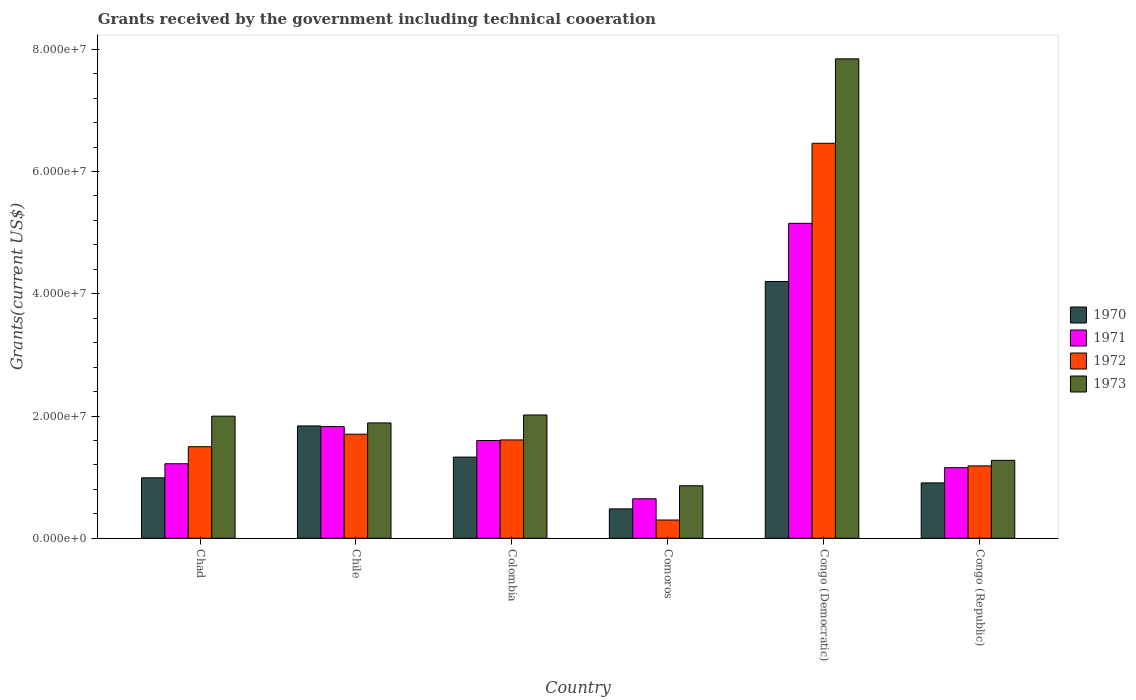How many different coloured bars are there?
Ensure brevity in your answer.  4. Are the number of bars per tick equal to the number of legend labels?
Give a very brief answer. Yes. Are the number of bars on each tick of the X-axis equal?
Your answer should be very brief. Yes. What is the label of the 6th group of bars from the left?
Your answer should be very brief. Congo (Republic). What is the total grants received by the government in 1972 in Comoros?
Make the answer very short. 2.99e+06. Across all countries, what is the maximum total grants received by the government in 1972?
Your answer should be very brief. 6.46e+07. Across all countries, what is the minimum total grants received by the government in 1972?
Offer a very short reply. 2.99e+06. In which country was the total grants received by the government in 1972 maximum?
Your answer should be very brief. Congo (Democratic). In which country was the total grants received by the government in 1972 minimum?
Your answer should be compact. Comoros. What is the total total grants received by the government in 1972 in the graph?
Offer a very short reply. 1.28e+08. What is the difference between the total grants received by the government in 1972 in Chad and that in Chile?
Offer a terse response. -2.05e+06. What is the difference between the total grants received by the government in 1972 in Comoros and the total grants received by the government in 1970 in Chad?
Your response must be concise. -6.90e+06. What is the average total grants received by the government in 1972 per country?
Ensure brevity in your answer.  2.13e+07. What is the difference between the total grants received by the government of/in 1971 and total grants received by the government of/in 1970 in Comoros?
Keep it short and to the point. 1.65e+06. In how many countries, is the total grants received by the government in 1970 greater than 40000000 US$?
Your answer should be very brief. 1. What is the ratio of the total grants received by the government in 1973 in Chad to that in Congo (Democratic)?
Keep it short and to the point. 0.25. Is the total grants received by the government in 1972 in Colombia less than that in Congo (Democratic)?
Your answer should be very brief. Yes. Is the difference between the total grants received by the government in 1971 in Chad and Comoros greater than the difference between the total grants received by the government in 1970 in Chad and Comoros?
Make the answer very short. Yes. What is the difference between the highest and the second highest total grants received by the government in 1970?
Your response must be concise. 2.87e+07. What is the difference between the highest and the lowest total grants received by the government in 1970?
Offer a terse response. 3.72e+07. Is the sum of the total grants received by the government in 1973 in Chad and Congo (Republic) greater than the maximum total grants received by the government in 1971 across all countries?
Ensure brevity in your answer.  No. Is it the case that in every country, the sum of the total grants received by the government in 1971 and total grants received by the government in 1970 is greater than the sum of total grants received by the government in 1973 and total grants received by the government in 1972?
Offer a terse response. No. What does the 3rd bar from the right in Chad represents?
Keep it short and to the point. 1971. How many bars are there?
Give a very brief answer. 24. Are all the bars in the graph horizontal?
Offer a terse response. No. What is the difference between two consecutive major ticks on the Y-axis?
Keep it short and to the point. 2.00e+07. Are the values on the major ticks of Y-axis written in scientific E-notation?
Offer a very short reply. Yes. Does the graph contain any zero values?
Your answer should be very brief. No. How many legend labels are there?
Provide a succinct answer. 4. What is the title of the graph?
Ensure brevity in your answer.  Grants received by the government including technical cooeration. Does "2002" appear as one of the legend labels in the graph?
Ensure brevity in your answer.  No. What is the label or title of the Y-axis?
Offer a very short reply. Grants(current US$). What is the Grants(current US$) in 1970 in Chad?
Offer a terse response. 9.89e+06. What is the Grants(current US$) in 1971 in Chad?
Your response must be concise. 1.22e+07. What is the Grants(current US$) in 1972 in Chad?
Ensure brevity in your answer.  1.50e+07. What is the Grants(current US$) in 1973 in Chad?
Provide a short and direct response. 2.00e+07. What is the Grants(current US$) in 1970 in Chile?
Keep it short and to the point. 1.84e+07. What is the Grants(current US$) in 1971 in Chile?
Offer a very short reply. 1.83e+07. What is the Grants(current US$) of 1972 in Chile?
Your answer should be very brief. 1.70e+07. What is the Grants(current US$) of 1973 in Chile?
Offer a terse response. 1.89e+07. What is the Grants(current US$) of 1970 in Colombia?
Make the answer very short. 1.33e+07. What is the Grants(current US$) of 1971 in Colombia?
Offer a very short reply. 1.60e+07. What is the Grants(current US$) in 1972 in Colombia?
Offer a terse response. 1.61e+07. What is the Grants(current US$) of 1973 in Colombia?
Give a very brief answer. 2.02e+07. What is the Grants(current US$) in 1970 in Comoros?
Provide a short and direct response. 4.81e+06. What is the Grants(current US$) in 1971 in Comoros?
Your response must be concise. 6.46e+06. What is the Grants(current US$) in 1972 in Comoros?
Provide a succinct answer. 2.99e+06. What is the Grants(current US$) in 1973 in Comoros?
Ensure brevity in your answer.  8.59e+06. What is the Grants(current US$) of 1970 in Congo (Democratic)?
Provide a succinct answer. 4.20e+07. What is the Grants(current US$) of 1971 in Congo (Democratic)?
Ensure brevity in your answer.  5.15e+07. What is the Grants(current US$) in 1972 in Congo (Democratic)?
Provide a succinct answer. 6.46e+07. What is the Grants(current US$) in 1973 in Congo (Democratic)?
Give a very brief answer. 7.84e+07. What is the Grants(current US$) of 1970 in Congo (Republic)?
Your answer should be compact. 9.06e+06. What is the Grants(current US$) in 1971 in Congo (Republic)?
Keep it short and to the point. 1.16e+07. What is the Grants(current US$) in 1972 in Congo (Republic)?
Your answer should be compact. 1.18e+07. What is the Grants(current US$) in 1973 in Congo (Republic)?
Keep it short and to the point. 1.28e+07. Across all countries, what is the maximum Grants(current US$) in 1970?
Offer a terse response. 4.20e+07. Across all countries, what is the maximum Grants(current US$) in 1971?
Provide a succinct answer. 5.15e+07. Across all countries, what is the maximum Grants(current US$) in 1972?
Offer a terse response. 6.46e+07. Across all countries, what is the maximum Grants(current US$) in 1973?
Your response must be concise. 7.84e+07. Across all countries, what is the minimum Grants(current US$) in 1970?
Offer a terse response. 4.81e+06. Across all countries, what is the minimum Grants(current US$) in 1971?
Provide a succinct answer. 6.46e+06. Across all countries, what is the minimum Grants(current US$) in 1972?
Your response must be concise. 2.99e+06. Across all countries, what is the minimum Grants(current US$) in 1973?
Your answer should be very brief. 8.59e+06. What is the total Grants(current US$) in 1970 in the graph?
Offer a terse response. 9.74e+07. What is the total Grants(current US$) in 1971 in the graph?
Give a very brief answer. 1.16e+08. What is the total Grants(current US$) in 1972 in the graph?
Your answer should be very brief. 1.28e+08. What is the total Grants(current US$) in 1973 in the graph?
Your response must be concise. 1.59e+08. What is the difference between the Grants(current US$) in 1970 in Chad and that in Chile?
Your response must be concise. -8.49e+06. What is the difference between the Grants(current US$) of 1971 in Chad and that in Chile?
Keep it short and to the point. -6.08e+06. What is the difference between the Grants(current US$) of 1972 in Chad and that in Chile?
Offer a terse response. -2.05e+06. What is the difference between the Grants(current US$) of 1973 in Chad and that in Chile?
Your response must be concise. 1.11e+06. What is the difference between the Grants(current US$) in 1970 in Chad and that in Colombia?
Offer a very short reply. -3.39e+06. What is the difference between the Grants(current US$) in 1971 in Chad and that in Colombia?
Provide a succinct answer. -3.80e+06. What is the difference between the Grants(current US$) of 1972 in Chad and that in Colombia?
Your answer should be compact. -1.11e+06. What is the difference between the Grants(current US$) of 1973 in Chad and that in Colombia?
Ensure brevity in your answer.  -1.90e+05. What is the difference between the Grants(current US$) in 1970 in Chad and that in Comoros?
Keep it short and to the point. 5.08e+06. What is the difference between the Grants(current US$) of 1971 in Chad and that in Comoros?
Provide a succinct answer. 5.73e+06. What is the difference between the Grants(current US$) in 1972 in Chad and that in Comoros?
Provide a short and direct response. 1.20e+07. What is the difference between the Grants(current US$) of 1973 in Chad and that in Comoros?
Ensure brevity in your answer.  1.14e+07. What is the difference between the Grants(current US$) of 1970 in Chad and that in Congo (Democratic)?
Keep it short and to the point. -3.21e+07. What is the difference between the Grants(current US$) in 1971 in Chad and that in Congo (Democratic)?
Offer a very short reply. -3.93e+07. What is the difference between the Grants(current US$) in 1972 in Chad and that in Congo (Democratic)?
Provide a succinct answer. -4.96e+07. What is the difference between the Grants(current US$) in 1973 in Chad and that in Congo (Democratic)?
Your answer should be compact. -5.84e+07. What is the difference between the Grants(current US$) of 1970 in Chad and that in Congo (Republic)?
Keep it short and to the point. 8.30e+05. What is the difference between the Grants(current US$) of 1971 in Chad and that in Congo (Republic)?
Provide a short and direct response. 6.40e+05. What is the difference between the Grants(current US$) in 1972 in Chad and that in Congo (Republic)?
Offer a very short reply. 3.14e+06. What is the difference between the Grants(current US$) in 1973 in Chad and that in Congo (Republic)?
Your answer should be very brief. 7.23e+06. What is the difference between the Grants(current US$) of 1970 in Chile and that in Colombia?
Your answer should be very brief. 5.10e+06. What is the difference between the Grants(current US$) of 1971 in Chile and that in Colombia?
Ensure brevity in your answer.  2.28e+06. What is the difference between the Grants(current US$) of 1972 in Chile and that in Colombia?
Provide a short and direct response. 9.40e+05. What is the difference between the Grants(current US$) of 1973 in Chile and that in Colombia?
Your response must be concise. -1.30e+06. What is the difference between the Grants(current US$) in 1970 in Chile and that in Comoros?
Your answer should be very brief. 1.36e+07. What is the difference between the Grants(current US$) of 1971 in Chile and that in Comoros?
Your answer should be compact. 1.18e+07. What is the difference between the Grants(current US$) of 1972 in Chile and that in Comoros?
Ensure brevity in your answer.  1.40e+07. What is the difference between the Grants(current US$) of 1973 in Chile and that in Comoros?
Your response must be concise. 1.03e+07. What is the difference between the Grants(current US$) in 1970 in Chile and that in Congo (Democratic)?
Give a very brief answer. -2.36e+07. What is the difference between the Grants(current US$) in 1971 in Chile and that in Congo (Democratic)?
Provide a succinct answer. -3.32e+07. What is the difference between the Grants(current US$) of 1972 in Chile and that in Congo (Democratic)?
Ensure brevity in your answer.  -4.76e+07. What is the difference between the Grants(current US$) of 1973 in Chile and that in Congo (Democratic)?
Your answer should be very brief. -5.96e+07. What is the difference between the Grants(current US$) in 1970 in Chile and that in Congo (Republic)?
Give a very brief answer. 9.32e+06. What is the difference between the Grants(current US$) in 1971 in Chile and that in Congo (Republic)?
Keep it short and to the point. 6.72e+06. What is the difference between the Grants(current US$) of 1972 in Chile and that in Congo (Republic)?
Offer a very short reply. 5.19e+06. What is the difference between the Grants(current US$) in 1973 in Chile and that in Congo (Republic)?
Provide a short and direct response. 6.12e+06. What is the difference between the Grants(current US$) of 1970 in Colombia and that in Comoros?
Your answer should be very brief. 8.47e+06. What is the difference between the Grants(current US$) in 1971 in Colombia and that in Comoros?
Your answer should be very brief. 9.53e+06. What is the difference between the Grants(current US$) in 1972 in Colombia and that in Comoros?
Provide a succinct answer. 1.31e+07. What is the difference between the Grants(current US$) of 1973 in Colombia and that in Comoros?
Provide a short and direct response. 1.16e+07. What is the difference between the Grants(current US$) of 1970 in Colombia and that in Congo (Democratic)?
Give a very brief answer. -2.87e+07. What is the difference between the Grants(current US$) of 1971 in Colombia and that in Congo (Democratic)?
Your answer should be very brief. -3.55e+07. What is the difference between the Grants(current US$) in 1972 in Colombia and that in Congo (Democratic)?
Keep it short and to the point. -4.85e+07. What is the difference between the Grants(current US$) in 1973 in Colombia and that in Congo (Democratic)?
Your response must be concise. -5.83e+07. What is the difference between the Grants(current US$) in 1970 in Colombia and that in Congo (Republic)?
Your answer should be very brief. 4.22e+06. What is the difference between the Grants(current US$) in 1971 in Colombia and that in Congo (Republic)?
Offer a very short reply. 4.44e+06. What is the difference between the Grants(current US$) in 1972 in Colombia and that in Congo (Republic)?
Provide a short and direct response. 4.25e+06. What is the difference between the Grants(current US$) in 1973 in Colombia and that in Congo (Republic)?
Ensure brevity in your answer.  7.42e+06. What is the difference between the Grants(current US$) of 1970 in Comoros and that in Congo (Democratic)?
Provide a short and direct response. -3.72e+07. What is the difference between the Grants(current US$) of 1971 in Comoros and that in Congo (Democratic)?
Your answer should be very brief. -4.51e+07. What is the difference between the Grants(current US$) in 1972 in Comoros and that in Congo (Democratic)?
Offer a very short reply. -6.16e+07. What is the difference between the Grants(current US$) of 1973 in Comoros and that in Congo (Democratic)?
Make the answer very short. -6.98e+07. What is the difference between the Grants(current US$) in 1970 in Comoros and that in Congo (Republic)?
Give a very brief answer. -4.25e+06. What is the difference between the Grants(current US$) in 1971 in Comoros and that in Congo (Republic)?
Give a very brief answer. -5.09e+06. What is the difference between the Grants(current US$) of 1972 in Comoros and that in Congo (Republic)?
Offer a terse response. -8.85e+06. What is the difference between the Grants(current US$) in 1973 in Comoros and that in Congo (Republic)?
Ensure brevity in your answer.  -4.16e+06. What is the difference between the Grants(current US$) in 1970 in Congo (Democratic) and that in Congo (Republic)?
Keep it short and to the point. 3.30e+07. What is the difference between the Grants(current US$) of 1971 in Congo (Democratic) and that in Congo (Republic)?
Keep it short and to the point. 4.00e+07. What is the difference between the Grants(current US$) in 1972 in Congo (Democratic) and that in Congo (Republic)?
Offer a very short reply. 5.28e+07. What is the difference between the Grants(current US$) in 1973 in Congo (Democratic) and that in Congo (Republic)?
Offer a terse response. 6.57e+07. What is the difference between the Grants(current US$) of 1970 in Chad and the Grants(current US$) of 1971 in Chile?
Make the answer very short. -8.38e+06. What is the difference between the Grants(current US$) in 1970 in Chad and the Grants(current US$) in 1972 in Chile?
Ensure brevity in your answer.  -7.14e+06. What is the difference between the Grants(current US$) in 1970 in Chad and the Grants(current US$) in 1973 in Chile?
Provide a succinct answer. -8.98e+06. What is the difference between the Grants(current US$) of 1971 in Chad and the Grants(current US$) of 1972 in Chile?
Keep it short and to the point. -4.84e+06. What is the difference between the Grants(current US$) in 1971 in Chad and the Grants(current US$) in 1973 in Chile?
Keep it short and to the point. -6.68e+06. What is the difference between the Grants(current US$) in 1972 in Chad and the Grants(current US$) in 1973 in Chile?
Ensure brevity in your answer.  -3.89e+06. What is the difference between the Grants(current US$) of 1970 in Chad and the Grants(current US$) of 1971 in Colombia?
Keep it short and to the point. -6.10e+06. What is the difference between the Grants(current US$) in 1970 in Chad and the Grants(current US$) in 1972 in Colombia?
Your answer should be compact. -6.20e+06. What is the difference between the Grants(current US$) of 1970 in Chad and the Grants(current US$) of 1973 in Colombia?
Your response must be concise. -1.03e+07. What is the difference between the Grants(current US$) in 1971 in Chad and the Grants(current US$) in 1972 in Colombia?
Provide a short and direct response. -3.90e+06. What is the difference between the Grants(current US$) in 1971 in Chad and the Grants(current US$) in 1973 in Colombia?
Offer a terse response. -7.98e+06. What is the difference between the Grants(current US$) of 1972 in Chad and the Grants(current US$) of 1973 in Colombia?
Keep it short and to the point. -5.19e+06. What is the difference between the Grants(current US$) in 1970 in Chad and the Grants(current US$) in 1971 in Comoros?
Provide a succinct answer. 3.43e+06. What is the difference between the Grants(current US$) of 1970 in Chad and the Grants(current US$) of 1972 in Comoros?
Offer a very short reply. 6.90e+06. What is the difference between the Grants(current US$) in 1970 in Chad and the Grants(current US$) in 1973 in Comoros?
Your answer should be very brief. 1.30e+06. What is the difference between the Grants(current US$) of 1971 in Chad and the Grants(current US$) of 1972 in Comoros?
Keep it short and to the point. 9.20e+06. What is the difference between the Grants(current US$) in 1971 in Chad and the Grants(current US$) in 1973 in Comoros?
Keep it short and to the point. 3.60e+06. What is the difference between the Grants(current US$) of 1972 in Chad and the Grants(current US$) of 1973 in Comoros?
Provide a succinct answer. 6.39e+06. What is the difference between the Grants(current US$) in 1970 in Chad and the Grants(current US$) in 1971 in Congo (Democratic)?
Provide a succinct answer. -4.16e+07. What is the difference between the Grants(current US$) of 1970 in Chad and the Grants(current US$) of 1972 in Congo (Democratic)?
Your answer should be compact. -5.47e+07. What is the difference between the Grants(current US$) in 1970 in Chad and the Grants(current US$) in 1973 in Congo (Democratic)?
Your answer should be compact. -6.85e+07. What is the difference between the Grants(current US$) of 1971 in Chad and the Grants(current US$) of 1972 in Congo (Democratic)?
Your answer should be very brief. -5.24e+07. What is the difference between the Grants(current US$) of 1971 in Chad and the Grants(current US$) of 1973 in Congo (Democratic)?
Your answer should be compact. -6.62e+07. What is the difference between the Grants(current US$) in 1972 in Chad and the Grants(current US$) in 1973 in Congo (Democratic)?
Provide a short and direct response. -6.34e+07. What is the difference between the Grants(current US$) in 1970 in Chad and the Grants(current US$) in 1971 in Congo (Republic)?
Your answer should be compact. -1.66e+06. What is the difference between the Grants(current US$) in 1970 in Chad and the Grants(current US$) in 1972 in Congo (Republic)?
Your answer should be compact. -1.95e+06. What is the difference between the Grants(current US$) of 1970 in Chad and the Grants(current US$) of 1973 in Congo (Republic)?
Give a very brief answer. -2.86e+06. What is the difference between the Grants(current US$) of 1971 in Chad and the Grants(current US$) of 1973 in Congo (Republic)?
Your answer should be compact. -5.60e+05. What is the difference between the Grants(current US$) in 1972 in Chad and the Grants(current US$) in 1973 in Congo (Republic)?
Keep it short and to the point. 2.23e+06. What is the difference between the Grants(current US$) of 1970 in Chile and the Grants(current US$) of 1971 in Colombia?
Your response must be concise. 2.39e+06. What is the difference between the Grants(current US$) of 1970 in Chile and the Grants(current US$) of 1972 in Colombia?
Offer a terse response. 2.29e+06. What is the difference between the Grants(current US$) of 1970 in Chile and the Grants(current US$) of 1973 in Colombia?
Your response must be concise. -1.79e+06. What is the difference between the Grants(current US$) of 1971 in Chile and the Grants(current US$) of 1972 in Colombia?
Your response must be concise. 2.18e+06. What is the difference between the Grants(current US$) in 1971 in Chile and the Grants(current US$) in 1973 in Colombia?
Your answer should be compact. -1.90e+06. What is the difference between the Grants(current US$) in 1972 in Chile and the Grants(current US$) in 1973 in Colombia?
Offer a very short reply. -3.14e+06. What is the difference between the Grants(current US$) in 1970 in Chile and the Grants(current US$) in 1971 in Comoros?
Provide a short and direct response. 1.19e+07. What is the difference between the Grants(current US$) in 1970 in Chile and the Grants(current US$) in 1972 in Comoros?
Provide a succinct answer. 1.54e+07. What is the difference between the Grants(current US$) of 1970 in Chile and the Grants(current US$) of 1973 in Comoros?
Provide a succinct answer. 9.79e+06. What is the difference between the Grants(current US$) in 1971 in Chile and the Grants(current US$) in 1972 in Comoros?
Offer a terse response. 1.53e+07. What is the difference between the Grants(current US$) in 1971 in Chile and the Grants(current US$) in 1973 in Comoros?
Provide a short and direct response. 9.68e+06. What is the difference between the Grants(current US$) in 1972 in Chile and the Grants(current US$) in 1973 in Comoros?
Offer a terse response. 8.44e+06. What is the difference between the Grants(current US$) of 1970 in Chile and the Grants(current US$) of 1971 in Congo (Democratic)?
Your answer should be compact. -3.31e+07. What is the difference between the Grants(current US$) of 1970 in Chile and the Grants(current US$) of 1972 in Congo (Democratic)?
Give a very brief answer. -4.62e+07. What is the difference between the Grants(current US$) in 1970 in Chile and the Grants(current US$) in 1973 in Congo (Democratic)?
Your answer should be very brief. -6.00e+07. What is the difference between the Grants(current US$) in 1971 in Chile and the Grants(current US$) in 1972 in Congo (Democratic)?
Offer a terse response. -4.64e+07. What is the difference between the Grants(current US$) of 1971 in Chile and the Grants(current US$) of 1973 in Congo (Democratic)?
Your response must be concise. -6.02e+07. What is the difference between the Grants(current US$) of 1972 in Chile and the Grants(current US$) of 1973 in Congo (Democratic)?
Give a very brief answer. -6.14e+07. What is the difference between the Grants(current US$) of 1970 in Chile and the Grants(current US$) of 1971 in Congo (Republic)?
Give a very brief answer. 6.83e+06. What is the difference between the Grants(current US$) of 1970 in Chile and the Grants(current US$) of 1972 in Congo (Republic)?
Your response must be concise. 6.54e+06. What is the difference between the Grants(current US$) in 1970 in Chile and the Grants(current US$) in 1973 in Congo (Republic)?
Ensure brevity in your answer.  5.63e+06. What is the difference between the Grants(current US$) of 1971 in Chile and the Grants(current US$) of 1972 in Congo (Republic)?
Your answer should be very brief. 6.43e+06. What is the difference between the Grants(current US$) of 1971 in Chile and the Grants(current US$) of 1973 in Congo (Republic)?
Provide a succinct answer. 5.52e+06. What is the difference between the Grants(current US$) of 1972 in Chile and the Grants(current US$) of 1973 in Congo (Republic)?
Provide a succinct answer. 4.28e+06. What is the difference between the Grants(current US$) in 1970 in Colombia and the Grants(current US$) in 1971 in Comoros?
Keep it short and to the point. 6.82e+06. What is the difference between the Grants(current US$) in 1970 in Colombia and the Grants(current US$) in 1972 in Comoros?
Ensure brevity in your answer.  1.03e+07. What is the difference between the Grants(current US$) of 1970 in Colombia and the Grants(current US$) of 1973 in Comoros?
Keep it short and to the point. 4.69e+06. What is the difference between the Grants(current US$) of 1971 in Colombia and the Grants(current US$) of 1972 in Comoros?
Offer a very short reply. 1.30e+07. What is the difference between the Grants(current US$) of 1971 in Colombia and the Grants(current US$) of 1973 in Comoros?
Make the answer very short. 7.40e+06. What is the difference between the Grants(current US$) of 1972 in Colombia and the Grants(current US$) of 1973 in Comoros?
Provide a short and direct response. 7.50e+06. What is the difference between the Grants(current US$) of 1970 in Colombia and the Grants(current US$) of 1971 in Congo (Democratic)?
Make the answer very short. -3.82e+07. What is the difference between the Grants(current US$) in 1970 in Colombia and the Grants(current US$) in 1972 in Congo (Democratic)?
Keep it short and to the point. -5.13e+07. What is the difference between the Grants(current US$) of 1970 in Colombia and the Grants(current US$) of 1973 in Congo (Democratic)?
Provide a short and direct response. -6.52e+07. What is the difference between the Grants(current US$) in 1971 in Colombia and the Grants(current US$) in 1972 in Congo (Democratic)?
Provide a succinct answer. -4.86e+07. What is the difference between the Grants(current US$) in 1971 in Colombia and the Grants(current US$) in 1973 in Congo (Democratic)?
Your response must be concise. -6.24e+07. What is the difference between the Grants(current US$) of 1972 in Colombia and the Grants(current US$) of 1973 in Congo (Democratic)?
Your answer should be compact. -6.23e+07. What is the difference between the Grants(current US$) of 1970 in Colombia and the Grants(current US$) of 1971 in Congo (Republic)?
Give a very brief answer. 1.73e+06. What is the difference between the Grants(current US$) in 1970 in Colombia and the Grants(current US$) in 1972 in Congo (Republic)?
Offer a terse response. 1.44e+06. What is the difference between the Grants(current US$) of 1970 in Colombia and the Grants(current US$) of 1973 in Congo (Republic)?
Offer a terse response. 5.30e+05. What is the difference between the Grants(current US$) in 1971 in Colombia and the Grants(current US$) in 1972 in Congo (Republic)?
Your answer should be compact. 4.15e+06. What is the difference between the Grants(current US$) of 1971 in Colombia and the Grants(current US$) of 1973 in Congo (Republic)?
Give a very brief answer. 3.24e+06. What is the difference between the Grants(current US$) in 1972 in Colombia and the Grants(current US$) in 1973 in Congo (Republic)?
Provide a short and direct response. 3.34e+06. What is the difference between the Grants(current US$) in 1970 in Comoros and the Grants(current US$) in 1971 in Congo (Democratic)?
Your answer should be compact. -4.67e+07. What is the difference between the Grants(current US$) in 1970 in Comoros and the Grants(current US$) in 1972 in Congo (Democratic)?
Offer a terse response. -5.98e+07. What is the difference between the Grants(current US$) of 1970 in Comoros and the Grants(current US$) of 1973 in Congo (Democratic)?
Offer a terse response. -7.36e+07. What is the difference between the Grants(current US$) in 1971 in Comoros and the Grants(current US$) in 1972 in Congo (Democratic)?
Your answer should be very brief. -5.82e+07. What is the difference between the Grants(current US$) of 1971 in Comoros and the Grants(current US$) of 1973 in Congo (Democratic)?
Ensure brevity in your answer.  -7.20e+07. What is the difference between the Grants(current US$) in 1972 in Comoros and the Grants(current US$) in 1973 in Congo (Democratic)?
Your answer should be very brief. -7.54e+07. What is the difference between the Grants(current US$) in 1970 in Comoros and the Grants(current US$) in 1971 in Congo (Republic)?
Offer a very short reply. -6.74e+06. What is the difference between the Grants(current US$) in 1970 in Comoros and the Grants(current US$) in 1972 in Congo (Republic)?
Provide a short and direct response. -7.03e+06. What is the difference between the Grants(current US$) in 1970 in Comoros and the Grants(current US$) in 1973 in Congo (Republic)?
Provide a short and direct response. -7.94e+06. What is the difference between the Grants(current US$) in 1971 in Comoros and the Grants(current US$) in 1972 in Congo (Republic)?
Make the answer very short. -5.38e+06. What is the difference between the Grants(current US$) in 1971 in Comoros and the Grants(current US$) in 1973 in Congo (Republic)?
Ensure brevity in your answer.  -6.29e+06. What is the difference between the Grants(current US$) in 1972 in Comoros and the Grants(current US$) in 1973 in Congo (Republic)?
Provide a short and direct response. -9.76e+06. What is the difference between the Grants(current US$) in 1970 in Congo (Democratic) and the Grants(current US$) in 1971 in Congo (Republic)?
Your answer should be compact. 3.05e+07. What is the difference between the Grants(current US$) of 1970 in Congo (Democratic) and the Grants(current US$) of 1972 in Congo (Republic)?
Ensure brevity in your answer.  3.02e+07. What is the difference between the Grants(current US$) of 1970 in Congo (Democratic) and the Grants(current US$) of 1973 in Congo (Republic)?
Make the answer very short. 2.93e+07. What is the difference between the Grants(current US$) in 1971 in Congo (Democratic) and the Grants(current US$) in 1972 in Congo (Republic)?
Make the answer very short. 3.97e+07. What is the difference between the Grants(current US$) in 1971 in Congo (Democratic) and the Grants(current US$) in 1973 in Congo (Republic)?
Your answer should be compact. 3.88e+07. What is the difference between the Grants(current US$) in 1972 in Congo (Democratic) and the Grants(current US$) in 1973 in Congo (Republic)?
Ensure brevity in your answer.  5.19e+07. What is the average Grants(current US$) in 1970 per country?
Your answer should be compact. 1.62e+07. What is the average Grants(current US$) of 1971 per country?
Your answer should be very brief. 1.93e+07. What is the average Grants(current US$) of 1972 per country?
Give a very brief answer. 2.13e+07. What is the average Grants(current US$) in 1973 per country?
Offer a very short reply. 2.65e+07. What is the difference between the Grants(current US$) in 1970 and Grants(current US$) in 1971 in Chad?
Provide a short and direct response. -2.30e+06. What is the difference between the Grants(current US$) in 1970 and Grants(current US$) in 1972 in Chad?
Keep it short and to the point. -5.09e+06. What is the difference between the Grants(current US$) in 1970 and Grants(current US$) in 1973 in Chad?
Offer a terse response. -1.01e+07. What is the difference between the Grants(current US$) in 1971 and Grants(current US$) in 1972 in Chad?
Offer a very short reply. -2.79e+06. What is the difference between the Grants(current US$) in 1971 and Grants(current US$) in 1973 in Chad?
Offer a very short reply. -7.79e+06. What is the difference between the Grants(current US$) of 1972 and Grants(current US$) of 1973 in Chad?
Keep it short and to the point. -5.00e+06. What is the difference between the Grants(current US$) in 1970 and Grants(current US$) in 1972 in Chile?
Offer a terse response. 1.35e+06. What is the difference between the Grants(current US$) of 1970 and Grants(current US$) of 1973 in Chile?
Your answer should be very brief. -4.90e+05. What is the difference between the Grants(current US$) in 1971 and Grants(current US$) in 1972 in Chile?
Provide a short and direct response. 1.24e+06. What is the difference between the Grants(current US$) of 1971 and Grants(current US$) of 1973 in Chile?
Provide a succinct answer. -6.00e+05. What is the difference between the Grants(current US$) of 1972 and Grants(current US$) of 1973 in Chile?
Provide a succinct answer. -1.84e+06. What is the difference between the Grants(current US$) of 1970 and Grants(current US$) of 1971 in Colombia?
Offer a very short reply. -2.71e+06. What is the difference between the Grants(current US$) of 1970 and Grants(current US$) of 1972 in Colombia?
Ensure brevity in your answer.  -2.81e+06. What is the difference between the Grants(current US$) of 1970 and Grants(current US$) of 1973 in Colombia?
Your answer should be very brief. -6.89e+06. What is the difference between the Grants(current US$) of 1971 and Grants(current US$) of 1972 in Colombia?
Provide a succinct answer. -1.00e+05. What is the difference between the Grants(current US$) in 1971 and Grants(current US$) in 1973 in Colombia?
Keep it short and to the point. -4.18e+06. What is the difference between the Grants(current US$) in 1972 and Grants(current US$) in 1973 in Colombia?
Give a very brief answer. -4.08e+06. What is the difference between the Grants(current US$) in 1970 and Grants(current US$) in 1971 in Comoros?
Provide a short and direct response. -1.65e+06. What is the difference between the Grants(current US$) of 1970 and Grants(current US$) of 1972 in Comoros?
Offer a terse response. 1.82e+06. What is the difference between the Grants(current US$) in 1970 and Grants(current US$) in 1973 in Comoros?
Provide a succinct answer. -3.78e+06. What is the difference between the Grants(current US$) in 1971 and Grants(current US$) in 1972 in Comoros?
Make the answer very short. 3.47e+06. What is the difference between the Grants(current US$) of 1971 and Grants(current US$) of 1973 in Comoros?
Your answer should be compact. -2.13e+06. What is the difference between the Grants(current US$) of 1972 and Grants(current US$) of 1973 in Comoros?
Your answer should be very brief. -5.60e+06. What is the difference between the Grants(current US$) of 1970 and Grants(current US$) of 1971 in Congo (Democratic)?
Your answer should be very brief. -9.51e+06. What is the difference between the Grants(current US$) of 1970 and Grants(current US$) of 1972 in Congo (Democratic)?
Your answer should be very brief. -2.26e+07. What is the difference between the Grants(current US$) in 1970 and Grants(current US$) in 1973 in Congo (Democratic)?
Your answer should be compact. -3.64e+07. What is the difference between the Grants(current US$) in 1971 and Grants(current US$) in 1972 in Congo (Democratic)?
Give a very brief answer. -1.31e+07. What is the difference between the Grants(current US$) of 1971 and Grants(current US$) of 1973 in Congo (Democratic)?
Your answer should be very brief. -2.69e+07. What is the difference between the Grants(current US$) in 1972 and Grants(current US$) in 1973 in Congo (Democratic)?
Offer a very short reply. -1.38e+07. What is the difference between the Grants(current US$) of 1970 and Grants(current US$) of 1971 in Congo (Republic)?
Make the answer very short. -2.49e+06. What is the difference between the Grants(current US$) of 1970 and Grants(current US$) of 1972 in Congo (Republic)?
Offer a terse response. -2.78e+06. What is the difference between the Grants(current US$) of 1970 and Grants(current US$) of 1973 in Congo (Republic)?
Offer a terse response. -3.69e+06. What is the difference between the Grants(current US$) of 1971 and Grants(current US$) of 1972 in Congo (Republic)?
Provide a succinct answer. -2.90e+05. What is the difference between the Grants(current US$) of 1971 and Grants(current US$) of 1973 in Congo (Republic)?
Your answer should be very brief. -1.20e+06. What is the difference between the Grants(current US$) in 1972 and Grants(current US$) in 1973 in Congo (Republic)?
Keep it short and to the point. -9.10e+05. What is the ratio of the Grants(current US$) in 1970 in Chad to that in Chile?
Make the answer very short. 0.54. What is the ratio of the Grants(current US$) of 1971 in Chad to that in Chile?
Your answer should be compact. 0.67. What is the ratio of the Grants(current US$) in 1972 in Chad to that in Chile?
Provide a short and direct response. 0.88. What is the ratio of the Grants(current US$) of 1973 in Chad to that in Chile?
Offer a terse response. 1.06. What is the ratio of the Grants(current US$) of 1970 in Chad to that in Colombia?
Provide a short and direct response. 0.74. What is the ratio of the Grants(current US$) in 1971 in Chad to that in Colombia?
Your answer should be very brief. 0.76. What is the ratio of the Grants(current US$) in 1973 in Chad to that in Colombia?
Your answer should be compact. 0.99. What is the ratio of the Grants(current US$) of 1970 in Chad to that in Comoros?
Your response must be concise. 2.06. What is the ratio of the Grants(current US$) in 1971 in Chad to that in Comoros?
Give a very brief answer. 1.89. What is the ratio of the Grants(current US$) of 1972 in Chad to that in Comoros?
Ensure brevity in your answer.  5.01. What is the ratio of the Grants(current US$) of 1973 in Chad to that in Comoros?
Your answer should be compact. 2.33. What is the ratio of the Grants(current US$) of 1970 in Chad to that in Congo (Democratic)?
Your answer should be very brief. 0.24. What is the ratio of the Grants(current US$) in 1971 in Chad to that in Congo (Democratic)?
Offer a very short reply. 0.24. What is the ratio of the Grants(current US$) in 1972 in Chad to that in Congo (Democratic)?
Provide a short and direct response. 0.23. What is the ratio of the Grants(current US$) in 1973 in Chad to that in Congo (Democratic)?
Offer a very short reply. 0.25. What is the ratio of the Grants(current US$) in 1970 in Chad to that in Congo (Republic)?
Your answer should be very brief. 1.09. What is the ratio of the Grants(current US$) in 1971 in Chad to that in Congo (Republic)?
Make the answer very short. 1.06. What is the ratio of the Grants(current US$) of 1972 in Chad to that in Congo (Republic)?
Your response must be concise. 1.27. What is the ratio of the Grants(current US$) in 1973 in Chad to that in Congo (Republic)?
Provide a short and direct response. 1.57. What is the ratio of the Grants(current US$) in 1970 in Chile to that in Colombia?
Ensure brevity in your answer.  1.38. What is the ratio of the Grants(current US$) of 1971 in Chile to that in Colombia?
Provide a succinct answer. 1.14. What is the ratio of the Grants(current US$) in 1972 in Chile to that in Colombia?
Provide a succinct answer. 1.06. What is the ratio of the Grants(current US$) in 1973 in Chile to that in Colombia?
Offer a terse response. 0.94. What is the ratio of the Grants(current US$) in 1970 in Chile to that in Comoros?
Offer a very short reply. 3.82. What is the ratio of the Grants(current US$) in 1971 in Chile to that in Comoros?
Your answer should be compact. 2.83. What is the ratio of the Grants(current US$) of 1972 in Chile to that in Comoros?
Offer a very short reply. 5.7. What is the ratio of the Grants(current US$) of 1973 in Chile to that in Comoros?
Your answer should be very brief. 2.2. What is the ratio of the Grants(current US$) in 1970 in Chile to that in Congo (Democratic)?
Give a very brief answer. 0.44. What is the ratio of the Grants(current US$) in 1971 in Chile to that in Congo (Democratic)?
Provide a succinct answer. 0.35. What is the ratio of the Grants(current US$) of 1972 in Chile to that in Congo (Democratic)?
Offer a very short reply. 0.26. What is the ratio of the Grants(current US$) of 1973 in Chile to that in Congo (Democratic)?
Provide a succinct answer. 0.24. What is the ratio of the Grants(current US$) in 1970 in Chile to that in Congo (Republic)?
Give a very brief answer. 2.03. What is the ratio of the Grants(current US$) of 1971 in Chile to that in Congo (Republic)?
Offer a terse response. 1.58. What is the ratio of the Grants(current US$) of 1972 in Chile to that in Congo (Republic)?
Give a very brief answer. 1.44. What is the ratio of the Grants(current US$) of 1973 in Chile to that in Congo (Republic)?
Ensure brevity in your answer.  1.48. What is the ratio of the Grants(current US$) of 1970 in Colombia to that in Comoros?
Your answer should be compact. 2.76. What is the ratio of the Grants(current US$) in 1971 in Colombia to that in Comoros?
Your answer should be very brief. 2.48. What is the ratio of the Grants(current US$) of 1972 in Colombia to that in Comoros?
Your response must be concise. 5.38. What is the ratio of the Grants(current US$) of 1973 in Colombia to that in Comoros?
Offer a very short reply. 2.35. What is the ratio of the Grants(current US$) of 1970 in Colombia to that in Congo (Democratic)?
Your answer should be compact. 0.32. What is the ratio of the Grants(current US$) in 1971 in Colombia to that in Congo (Democratic)?
Your answer should be compact. 0.31. What is the ratio of the Grants(current US$) of 1972 in Colombia to that in Congo (Democratic)?
Your answer should be very brief. 0.25. What is the ratio of the Grants(current US$) in 1973 in Colombia to that in Congo (Democratic)?
Keep it short and to the point. 0.26. What is the ratio of the Grants(current US$) of 1970 in Colombia to that in Congo (Republic)?
Your answer should be compact. 1.47. What is the ratio of the Grants(current US$) of 1971 in Colombia to that in Congo (Republic)?
Offer a terse response. 1.38. What is the ratio of the Grants(current US$) of 1972 in Colombia to that in Congo (Republic)?
Offer a very short reply. 1.36. What is the ratio of the Grants(current US$) of 1973 in Colombia to that in Congo (Republic)?
Offer a terse response. 1.58. What is the ratio of the Grants(current US$) of 1970 in Comoros to that in Congo (Democratic)?
Your response must be concise. 0.11. What is the ratio of the Grants(current US$) in 1971 in Comoros to that in Congo (Democratic)?
Give a very brief answer. 0.13. What is the ratio of the Grants(current US$) in 1972 in Comoros to that in Congo (Democratic)?
Keep it short and to the point. 0.05. What is the ratio of the Grants(current US$) of 1973 in Comoros to that in Congo (Democratic)?
Your answer should be very brief. 0.11. What is the ratio of the Grants(current US$) in 1970 in Comoros to that in Congo (Republic)?
Your answer should be very brief. 0.53. What is the ratio of the Grants(current US$) in 1971 in Comoros to that in Congo (Republic)?
Provide a succinct answer. 0.56. What is the ratio of the Grants(current US$) of 1972 in Comoros to that in Congo (Republic)?
Provide a succinct answer. 0.25. What is the ratio of the Grants(current US$) in 1973 in Comoros to that in Congo (Republic)?
Ensure brevity in your answer.  0.67. What is the ratio of the Grants(current US$) in 1970 in Congo (Democratic) to that in Congo (Republic)?
Your answer should be compact. 4.64. What is the ratio of the Grants(current US$) of 1971 in Congo (Democratic) to that in Congo (Republic)?
Provide a succinct answer. 4.46. What is the ratio of the Grants(current US$) of 1972 in Congo (Democratic) to that in Congo (Republic)?
Provide a short and direct response. 5.46. What is the ratio of the Grants(current US$) in 1973 in Congo (Democratic) to that in Congo (Republic)?
Make the answer very short. 6.15. What is the difference between the highest and the second highest Grants(current US$) in 1970?
Your answer should be compact. 2.36e+07. What is the difference between the highest and the second highest Grants(current US$) in 1971?
Your answer should be compact. 3.32e+07. What is the difference between the highest and the second highest Grants(current US$) in 1972?
Your answer should be compact. 4.76e+07. What is the difference between the highest and the second highest Grants(current US$) in 1973?
Provide a succinct answer. 5.83e+07. What is the difference between the highest and the lowest Grants(current US$) in 1970?
Give a very brief answer. 3.72e+07. What is the difference between the highest and the lowest Grants(current US$) of 1971?
Your answer should be very brief. 4.51e+07. What is the difference between the highest and the lowest Grants(current US$) in 1972?
Keep it short and to the point. 6.16e+07. What is the difference between the highest and the lowest Grants(current US$) in 1973?
Your answer should be compact. 6.98e+07. 